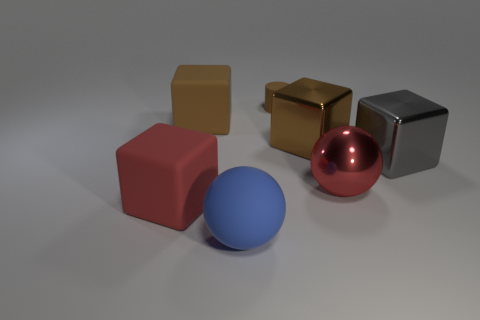There is a large thing that is the same color as the big metallic ball; what material is it?
Your response must be concise. Rubber. What size is the shiny thing behind the large gray block that is behind the big shiny sphere?
Your answer should be very brief. Large. What material is the block that is to the right of the brown matte cube and on the left side of the red metallic object?
Ensure brevity in your answer.  Metal. The tiny thing is what color?
Give a very brief answer. Brown. The object in front of the red matte thing has what shape?
Offer a terse response. Sphere. There is a cube on the left side of the brown matte thing that is in front of the small cylinder; is there a brown cylinder that is in front of it?
Your answer should be very brief. No. Is there any other thing that is the same shape as the small matte thing?
Provide a short and direct response. No. Are any brown rubber spheres visible?
Make the answer very short. No. Is the material of the big brown thing to the right of the brown matte block the same as the ball left of the red sphere?
Offer a very short reply. No. There is a red thing on the left side of the big block behind the metallic block that is behind the gray metallic cube; how big is it?
Your answer should be compact. Large. 